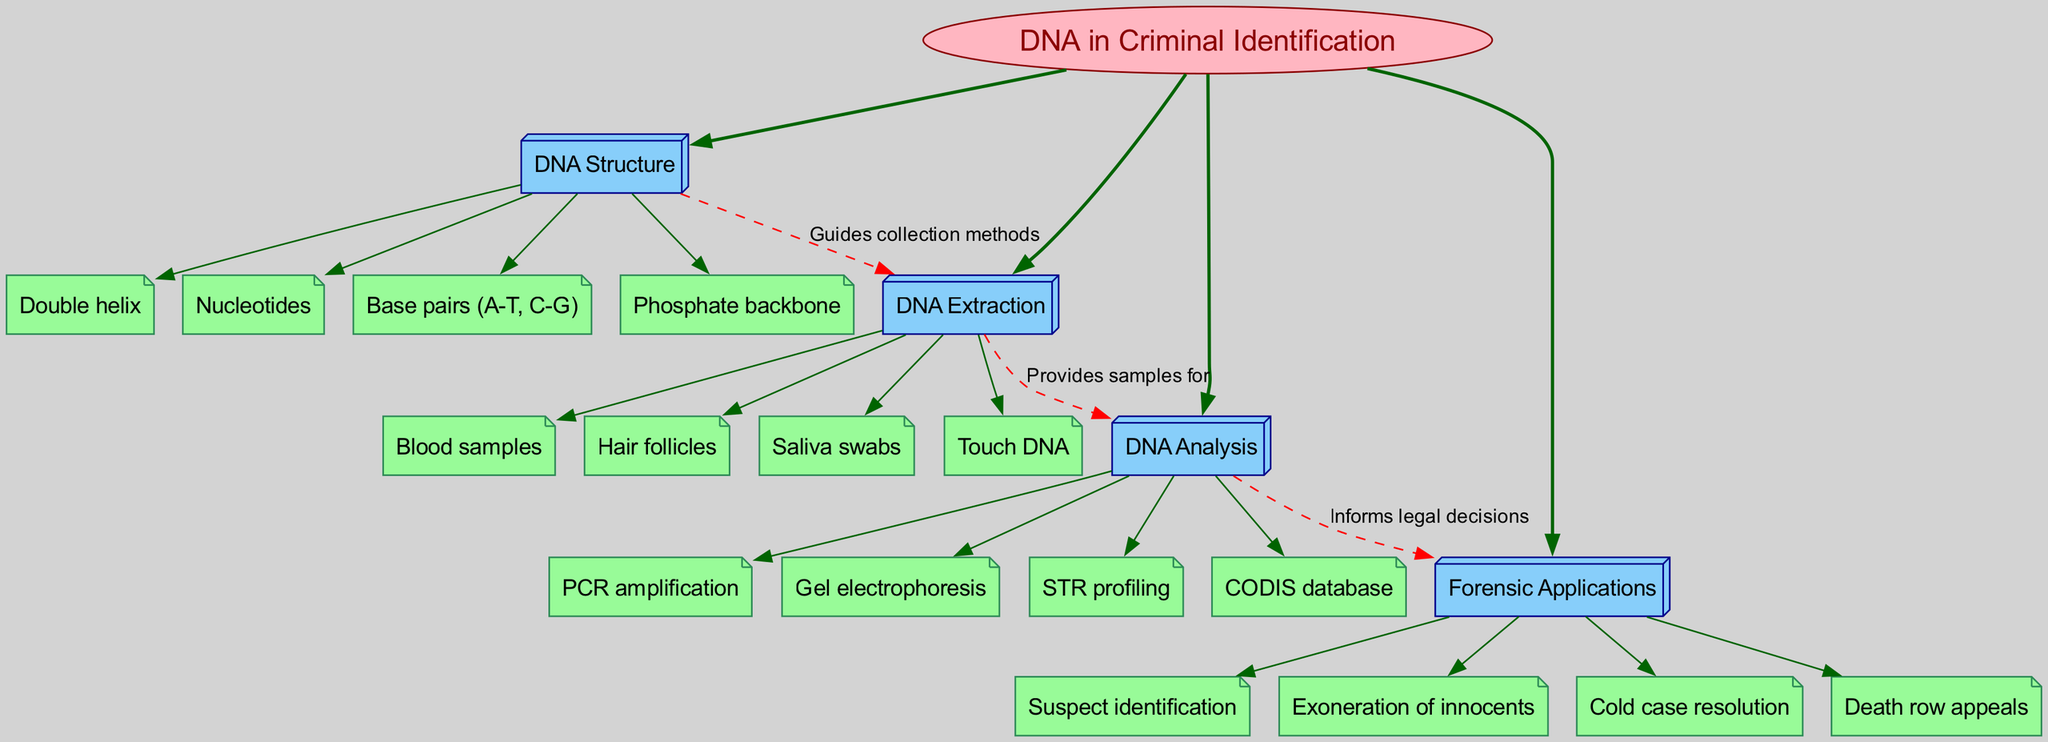What is the central topic of the diagram? The central topic is explicitly labeled as "DNA in Criminal Identification" in an ellipse shape at the top of the diagram.
Answer: DNA in Criminal Identification How many main branches does the diagram have? The diagram contains four main branches that relate to the central topic, which are listed as DNA Structure, DNA Extraction, DNA Analysis, and Forensic Applications.
Answer: 4 Which main branch contains "Saliva swabs"? "Saliva swabs" is a sub-branch listed under the main branch of DNA Extraction, as inferred from the breakdown provided in the diagram.
Answer: DNA Extraction What guides the collection methods in DNA extraction? The diagram shows an edge labeled "Guides collection methods" connecting the DNA Structure branch to the DNA Extraction branch, indicating that the structure itself guides how samples are collected.
Answer: DNA Structure What type of connection informs legal decisions? According to the connections shown in the diagram, the edge between DNA Analysis and Forensic Applications is labeled "Informs legal decisions," indicating this relationship informs legal outcomes.
Answer: Informs legal decisions Name one forensic application listed in the diagram. The diagram provides several options under the Forensic Applications branch, including "Suspect identification," "Exoneration of innocents," "Cold case resolution," and "Death row appeals." Any of these could be a valid answer.
Answer: Suspect identification What provides samples for DNA analysis? The connection between the DNA Extraction and DNA Analysis branches is labeled "Provides samples for," indicating that DNA extraction methods are responsible for supplying samples required for further analysis.
Answer: DNA Extraction How many types of DNA samples are listed in the diagram? There are four types of DNA samples specifically listed under the DNA Extraction branch: Blood samples, Hair follicles, Saliva swabs, and Touch DNA.
Answer: 4 What is a method listed under DNA Analysis? One method listed under the DNA Analysis branch of the diagram is "PCR amplification,” showing a specific technique used in analyzing DNA samples.
Answer: PCR amplification Which sub-branch is a part of DNA Structure? There are multiple sub-branches under DNA Structure, including the following listed: "Double helix," "Nucleotides," "Base pairs (A-T, C-G)," and "Phosphate backbone." Any one of these would qualify as an answer.
Answer: Double helix 